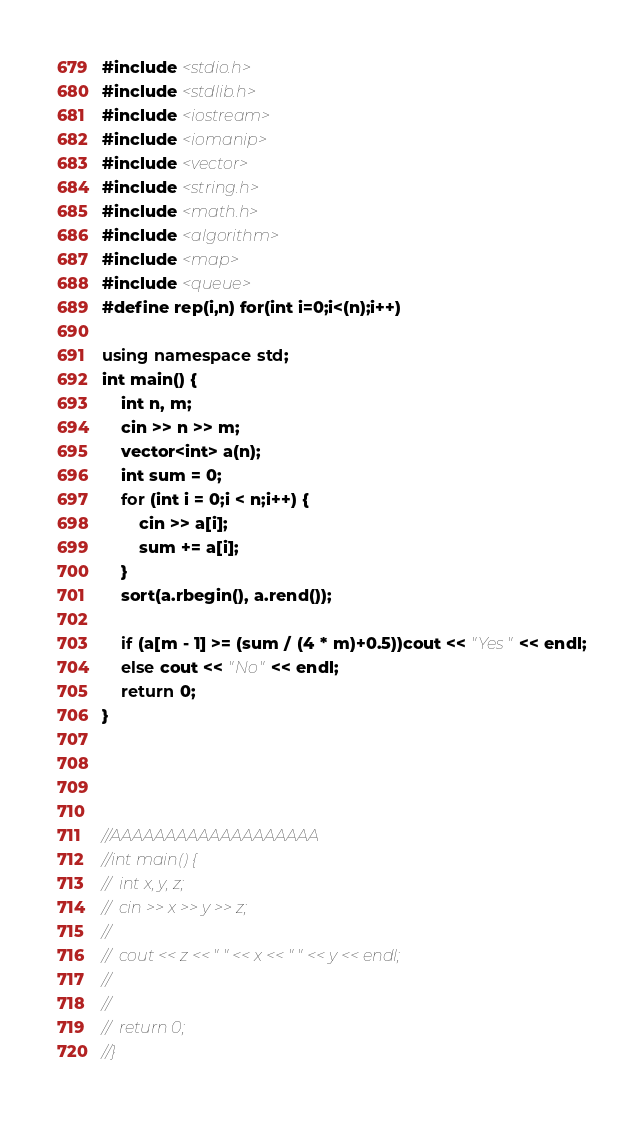<code> <loc_0><loc_0><loc_500><loc_500><_C++_>#include <stdio.h>
#include <stdlib.h>
#include <iostream>
#include <iomanip>
#include <vector>
#include <string.h>
#include <math.h>
#include <algorithm>
#include <map>
#include <queue>
#define rep(i,n) for(int i=0;i<(n);i++)

using namespace std;
int main() {
	int n, m;
	cin >> n >> m;
	vector<int> a(n);
	int sum = 0;
	for (int i = 0;i < n;i++) {
		cin >> a[i];
		sum += a[i];
	}
	sort(a.rbegin(), a.rend());

	if (a[m - 1] >= (sum / (4 * m)+0.5))cout << "Yes" << endl;
	else cout << "No" << endl;
	return 0;
}




//AAAAAAAAAAAAAAAAAAA
//int main() {
//	int x, y, z;
//	cin >> x >> y >> z;
//
//	cout << z << " " << x << " " << y << endl;
//
//
//	return 0;
//}</code> 